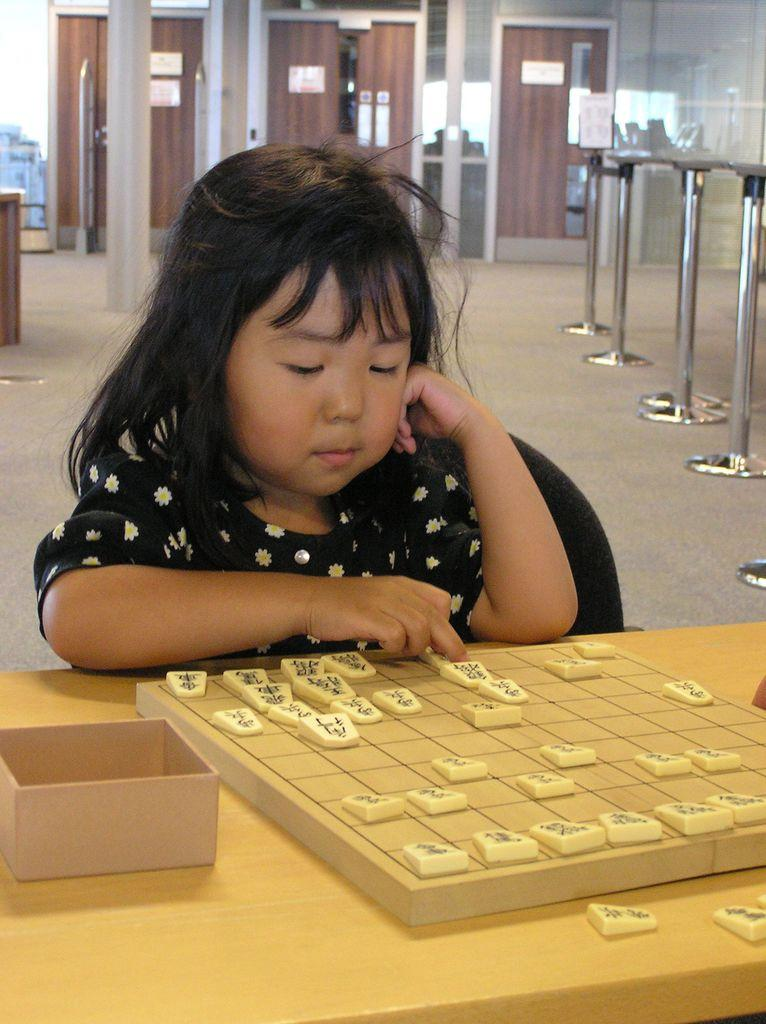Who is the main subject in the image? There is a girl in the image. What is the girl wearing? The girl is wearing a black dress. What is the girl doing in the image? The girl is playing a game. What can be seen on the left side of the image? There are tables on the left side of the image. What is visible at the back of the image? There is a door visible at the back of the image. What is the name of the company that the girl works for in the image? There is no information about a company or the girl's employment in the image. 